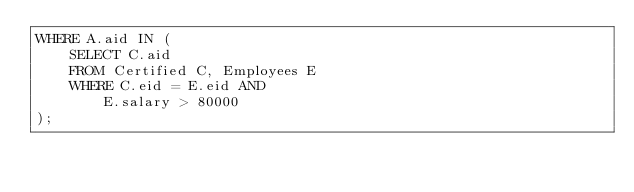<code> <loc_0><loc_0><loc_500><loc_500><_SQL_>WHERE A.aid IN (
	SELECT C.aid
	FROM Certified C, Employees E
	WHERE C.eid = E.eid AND
		E.salary > 80000
);
</code> 